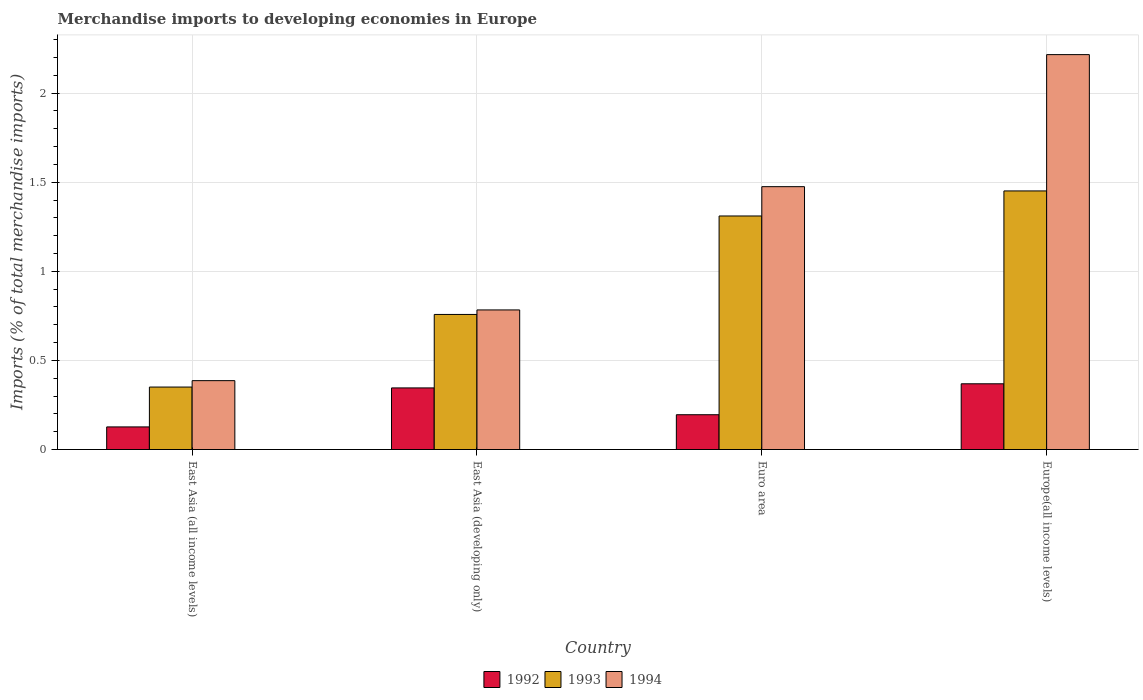How many different coloured bars are there?
Provide a short and direct response. 3. How many groups of bars are there?
Give a very brief answer. 4. Are the number of bars on each tick of the X-axis equal?
Ensure brevity in your answer.  Yes. What is the percentage total merchandise imports in 1994 in Europe(all income levels)?
Offer a very short reply. 2.22. Across all countries, what is the maximum percentage total merchandise imports in 1993?
Keep it short and to the point. 1.45. Across all countries, what is the minimum percentage total merchandise imports in 1992?
Offer a terse response. 0.13. In which country was the percentage total merchandise imports in 1993 maximum?
Provide a succinct answer. Europe(all income levels). In which country was the percentage total merchandise imports in 1993 minimum?
Ensure brevity in your answer.  East Asia (all income levels). What is the total percentage total merchandise imports in 1994 in the graph?
Make the answer very short. 4.86. What is the difference between the percentage total merchandise imports in 1992 in East Asia (developing only) and that in Europe(all income levels)?
Provide a short and direct response. -0.02. What is the difference between the percentage total merchandise imports in 1992 in East Asia (all income levels) and the percentage total merchandise imports in 1994 in Euro area?
Keep it short and to the point. -1.35. What is the average percentage total merchandise imports in 1993 per country?
Give a very brief answer. 0.97. What is the difference between the percentage total merchandise imports of/in 1993 and percentage total merchandise imports of/in 1994 in Euro area?
Offer a terse response. -0.16. In how many countries, is the percentage total merchandise imports in 1994 greater than 0.4 %?
Make the answer very short. 3. What is the ratio of the percentage total merchandise imports in 1993 in East Asia (all income levels) to that in Euro area?
Keep it short and to the point. 0.27. Is the difference between the percentage total merchandise imports in 1993 in East Asia (developing only) and Euro area greater than the difference between the percentage total merchandise imports in 1994 in East Asia (developing only) and Euro area?
Make the answer very short. Yes. What is the difference between the highest and the second highest percentage total merchandise imports in 1994?
Your response must be concise. -0.69. What is the difference between the highest and the lowest percentage total merchandise imports in 1994?
Make the answer very short. 1.83. Is the sum of the percentage total merchandise imports in 1993 in East Asia (all income levels) and East Asia (developing only) greater than the maximum percentage total merchandise imports in 1994 across all countries?
Provide a short and direct response. No. What does the 2nd bar from the left in Europe(all income levels) represents?
Ensure brevity in your answer.  1993. How many bars are there?
Give a very brief answer. 12. Are all the bars in the graph horizontal?
Provide a short and direct response. No. Are the values on the major ticks of Y-axis written in scientific E-notation?
Keep it short and to the point. No. Does the graph contain any zero values?
Offer a terse response. No. Where does the legend appear in the graph?
Provide a short and direct response. Bottom center. How many legend labels are there?
Offer a terse response. 3. How are the legend labels stacked?
Offer a very short reply. Horizontal. What is the title of the graph?
Your answer should be very brief. Merchandise imports to developing economies in Europe. Does "1992" appear as one of the legend labels in the graph?
Your answer should be compact. Yes. What is the label or title of the X-axis?
Give a very brief answer. Country. What is the label or title of the Y-axis?
Your response must be concise. Imports (% of total merchandise imports). What is the Imports (% of total merchandise imports) of 1992 in East Asia (all income levels)?
Your response must be concise. 0.13. What is the Imports (% of total merchandise imports) in 1993 in East Asia (all income levels)?
Offer a very short reply. 0.35. What is the Imports (% of total merchandise imports) of 1994 in East Asia (all income levels)?
Provide a succinct answer. 0.39. What is the Imports (% of total merchandise imports) in 1992 in East Asia (developing only)?
Your response must be concise. 0.35. What is the Imports (% of total merchandise imports) of 1993 in East Asia (developing only)?
Your response must be concise. 0.76. What is the Imports (% of total merchandise imports) in 1994 in East Asia (developing only)?
Keep it short and to the point. 0.78. What is the Imports (% of total merchandise imports) of 1992 in Euro area?
Ensure brevity in your answer.  0.2. What is the Imports (% of total merchandise imports) of 1993 in Euro area?
Make the answer very short. 1.31. What is the Imports (% of total merchandise imports) in 1994 in Euro area?
Offer a terse response. 1.48. What is the Imports (% of total merchandise imports) in 1992 in Europe(all income levels)?
Ensure brevity in your answer.  0.37. What is the Imports (% of total merchandise imports) of 1993 in Europe(all income levels)?
Keep it short and to the point. 1.45. What is the Imports (% of total merchandise imports) of 1994 in Europe(all income levels)?
Your response must be concise. 2.22. Across all countries, what is the maximum Imports (% of total merchandise imports) in 1992?
Offer a very short reply. 0.37. Across all countries, what is the maximum Imports (% of total merchandise imports) of 1993?
Your answer should be compact. 1.45. Across all countries, what is the maximum Imports (% of total merchandise imports) of 1994?
Keep it short and to the point. 2.22. Across all countries, what is the minimum Imports (% of total merchandise imports) of 1992?
Give a very brief answer. 0.13. Across all countries, what is the minimum Imports (% of total merchandise imports) of 1993?
Your answer should be very brief. 0.35. Across all countries, what is the minimum Imports (% of total merchandise imports) of 1994?
Offer a very short reply. 0.39. What is the total Imports (% of total merchandise imports) in 1992 in the graph?
Make the answer very short. 1.04. What is the total Imports (% of total merchandise imports) in 1993 in the graph?
Provide a succinct answer. 3.87. What is the total Imports (% of total merchandise imports) of 1994 in the graph?
Make the answer very short. 4.86. What is the difference between the Imports (% of total merchandise imports) in 1992 in East Asia (all income levels) and that in East Asia (developing only)?
Provide a succinct answer. -0.22. What is the difference between the Imports (% of total merchandise imports) in 1993 in East Asia (all income levels) and that in East Asia (developing only)?
Provide a short and direct response. -0.41. What is the difference between the Imports (% of total merchandise imports) in 1994 in East Asia (all income levels) and that in East Asia (developing only)?
Your answer should be compact. -0.4. What is the difference between the Imports (% of total merchandise imports) in 1992 in East Asia (all income levels) and that in Euro area?
Your response must be concise. -0.07. What is the difference between the Imports (% of total merchandise imports) of 1993 in East Asia (all income levels) and that in Euro area?
Your response must be concise. -0.96. What is the difference between the Imports (% of total merchandise imports) in 1994 in East Asia (all income levels) and that in Euro area?
Offer a terse response. -1.09. What is the difference between the Imports (% of total merchandise imports) in 1992 in East Asia (all income levels) and that in Europe(all income levels)?
Offer a very short reply. -0.24. What is the difference between the Imports (% of total merchandise imports) of 1993 in East Asia (all income levels) and that in Europe(all income levels)?
Offer a terse response. -1.1. What is the difference between the Imports (% of total merchandise imports) in 1994 in East Asia (all income levels) and that in Europe(all income levels)?
Ensure brevity in your answer.  -1.83. What is the difference between the Imports (% of total merchandise imports) in 1992 in East Asia (developing only) and that in Euro area?
Your answer should be compact. 0.15. What is the difference between the Imports (% of total merchandise imports) in 1993 in East Asia (developing only) and that in Euro area?
Provide a succinct answer. -0.55. What is the difference between the Imports (% of total merchandise imports) of 1994 in East Asia (developing only) and that in Euro area?
Provide a succinct answer. -0.69. What is the difference between the Imports (% of total merchandise imports) of 1992 in East Asia (developing only) and that in Europe(all income levels)?
Your response must be concise. -0.02. What is the difference between the Imports (% of total merchandise imports) in 1993 in East Asia (developing only) and that in Europe(all income levels)?
Offer a very short reply. -0.69. What is the difference between the Imports (% of total merchandise imports) of 1994 in East Asia (developing only) and that in Europe(all income levels)?
Make the answer very short. -1.43. What is the difference between the Imports (% of total merchandise imports) in 1992 in Euro area and that in Europe(all income levels)?
Offer a terse response. -0.17. What is the difference between the Imports (% of total merchandise imports) of 1993 in Euro area and that in Europe(all income levels)?
Your answer should be compact. -0.14. What is the difference between the Imports (% of total merchandise imports) in 1994 in Euro area and that in Europe(all income levels)?
Provide a short and direct response. -0.74. What is the difference between the Imports (% of total merchandise imports) in 1992 in East Asia (all income levels) and the Imports (% of total merchandise imports) in 1993 in East Asia (developing only)?
Offer a very short reply. -0.63. What is the difference between the Imports (% of total merchandise imports) of 1992 in East Asia (all income levels) and the Imports (% of total merchandise imports) of 1994 in East Asia (developing only)?
Your response must be concise. -0.66. What is the difference between the Imports (% of total merchandise imports) in 1993 in East Asia (all income levels) and the Imports (% of total merchandise imports) in 1994 in East Asia (developing only)?
Ensure brevity in your answer.  -0.43. What is the difference between the Imports (% of total merchandise imports) of 1992 in East Asia (all income levels) and the Imports (% of total merchandise imports) of 1993 in Euro area?
Your response must be concise. -1.18. What is the difference between the Imports (% of total merchandise imports) of 1992 in East Asia (all income levels) and the Imports (% of total merchandise imports) of 1994 in Euro area?
Offer a very short reply. -1.35. What is the difference between the Imports (% of total merchandise imports) of 1993 in East Asia (all income levels) and the Imports (% of total merchandise imports) of 1994 in Euro area?
Provide a succinct answer. -1.12. What is the difference between the Imports (% of total merchandise imports) of 1992 in East Asia (all income levels) and the Imports (% of total merchandise imports) of 1993 in Europe(all income levels)?
Offer a terse response. -1.32. What is the difference between the Imports (% of total merchandise imports) of 1992 in East Asia (all income levels) and the Imports (% of total merchandise imports) of 1994 in Europe(all income levels)?
Your answer should be compact. -2.09. What is the difference between the Imports (% of total merchandise imports) in 1993 in East Asia (all income levels) and the Imports (% of total merchandise imports) in 1994 in Europe(all income levels)?
Make the answer very short. -1.87. What is the difference between the Imports (% of total merchandise imports) of 1992 in East Asia (developing only) and the Imports (% of total merchandise imports) of 1993 in Euro area?
Give a very brief answer. -0.96. What is the difference between the Imports (% of total merchandise imports) of 1992 in East Asia (developing only) and the Imports (% of total merchandise imports) of 1994 in Euro area?
Offer a terse response. -1.13. What is the difference between the Imports (% of total merchandise imports) in 1993 in East Asia (developing only) and the Imports (% of total merchandise imports) in 1994 in Euro area?
Keep it short and to the point. -0.72. What is the difference between the Imports (% of total merchandise imports) of 1992 in East Asia (developing only) and the Imports (% of total merchandise imports) of 1993 in Europe(all income levels)?
Provide a succinct answer. -1.11. What is the difference between the Imports (% of total merchandise imports) of 1992 in East Asia (developing only) and the Imports (% of total merchandise imports) of 1994 in Europe(all income levels)?
Your response must be concise. -1.87. What is the difference between the Imports (% of total merchandise imports) of 1993 in East Asia (developing only) and the Imports (% of total merchandise imports) of 1994 in Europe(all income levels)?
Your response must be concise. -1.46. What is the difference between the Imports (% of total merchandise imports) in 1992 in Euro area and the Imports (% of total merchandise imports) in 1993 in Europe(all income levels)?
Your answer should be compact. -1.26. What is the difference between the Imports (% of total merchandise imports) in 1992 in Euro area and the Imports (% of total merchandise imports) in 1994 in Europe(all income levels)?
Offer a terse response. -2.02. What is the difference between the Imports (% of total merchandise imports) of 1993 in Euro area and the Imports (% of total merchandise imports) of 1994 in Europe(all income levels)?
Your answer should be compact. -0.91. What is the average Imports (% of total merchandise imports) of 1992 per country?
Make the answer very short. 0.26. What is the average Imports (% of total merchandise imports) of 1993 per country?
Give a very brief answer. 0.97. What is the average Imports (% of total merchandise imports) in 1994 per country?
Your answer should be compact. 1.22. What is the difference between the Imports (% of total merchandise imports) in 1992 and Imports (% of total merchandise imports) in 1993 in East Asia (all income levels)?
Offer a very short reply. -0.22. What is the difference between the Imports (% of total merchandise imports) in 1992 and Imports (% of total merchandise imports) in 1994 in East Asia (all income levels)?
Your answer should be compact. -0.26. What is the difference between the Imports (% of total merchandise imports) of 1993 and Imports (% of total merchandise imports) of 1994 in East Asia (all income levels)?
Keep it short and to the point. -0.04. What is the difference between the Imports (% of total merchandise imports) of 1992 and Imports (% of total merchandise imports) of 1993 in East Asia (developing only)?
Offer a terse response. -0.41. What is the difference between the Imports (% of total merchandise imports) in 1992 and Imports (% of total merchandise imports) in 1994 in East Asia (developing only)?
Offer a very short reply. -0.44. What is the difference between the Imports (% of total merchandise imports) of 1993 and Imports (% of total merchandise imports) of 1994 in East Asia (developing only)?
Offer a terse response. -0.03. What is the difference between the Imports (% of total merchandise imports) of 1992 and Imports (% of total merchandise imports) of 1993 in Euro area?
Offer a very short reply. -1.12. What is the difference between the Imports (% of total merchandise imports) of 1992 and Imports (% of total merchandise imports) of 1994 in Euro area?
Ensure brevity in your answer.  -1.28. What is the difference between the Imports (% of total merchandise imports) of 1993 and Imports (% of total merchandise imports) of 1994 in Euro area?
Ensure brevity in your answer.  -0.16. What is the difference between the Imports (% of total merchandise imports) in 1992 and Imports (% of total merchandise imports) in 1993 in Europe(all income levels)?
Your answer should be compact. -1.08. What is the difference between the Imports (% of total merchandise imports) in 1992 and Imports (% of total merchandise imports) in 1994 in Europe(all income levels)?
Your response must be concise. -1.85. What is the difference between the Imports (% of total merchandise imports) in 1993 and Imports (% of total merchandise imports) in 1994 in Europe(all income levels)?
Provide a succinct answer. -0.76. What is the ratio of the Imports (% of total merchandise imports) in 1992 in East Asia (all income levels) to that in East Asia (developing only)?
Your answer should be very brief. 0.37. What is the ratio of the Imports (% of total merchandise imports) of 1993 in East Asia (all income levels) to that in East Asia (developing only)?
Offer a very short reply. 0.46. What is the ratio of the Imports (% of total merchandise imports) of 1994 in East Asia (all income levels) to that in East Asia (developing only)?
Your answer should be compact. 0.49. What is the ratio of the Imports (% of total merchandise imports) of 1992 in East Asia (all income levels) to that in Euro area?
Your answer should be compact. 0.65. What is the ratio of the Imports (% of total merchandise imports) in 1993 in East Asia (all income levels) to that in Euro area?
Provide a short and direct response. 0.27. What is the ratio of the Imports (% of total merchandise imports) of 1994 in East Asia (all income levels) to that in Euro area?
Provide a succinct answer. 0.26. What is the ratio of the Imports (% of total merchandise imports) in 1992 in East Asia (all income levels) to that in Europe(all income levels)?
Make the answer very short. 0.34. What is the ratio of the Imports (% of total merchandise imports) in 1993 in East Asia (all income levels) to that in Europe(all income levels)?
Your answer should be compact. 0.24. What is the ratio of the Imports (% of total merchandise imports) in 1994 in East Asia (all income levels) to that in Europe(all income levels)?
Give a very brief answer. 0.17. What is the ratio of the Imports (% of total merchandise imports) of 1992 in East Asia (developing only) to that in Euro area?
Ensure brevity in your answer.  1.77. What is the ratio of the Imports (% of total merchandise imports) in 1993 in East Asia (developing only) to that in Euro area?
Keep it short and to the point. 0.58. What is the ratio of the Imports (% of total merchandise imports) of 1994 in East Asia (developing only) to that in Euro area?
Provide a succinct answer. 0.53. What is the ratio of the Imports (% of total merchandise imports) of 1992 in East Asia (developing only) to that in Europe(all income levels)?
Make the answer very short. 0.94. What is the ratio of the Imports (% of total merchandise imports) in 1993 in East Asia (developing only) to that in Europe(all income levels)?
Keep it short and to the point. 0.52. What is the ratio of the Imports (% of total merchandise imports) in 1994 in East Asia (developing only) to that in Europe(all income levels)?
Ensure brevity in your answer.  0.35. What is the ratio of the Imports (% of total merchandise imports) in 1992 in Euro area to that in Europe(all income levels)?
Make the answer very short. 0.53. What is the ratio of the Imports (% of total merchandise imports) of 1993 in Euro area to that in Europe(all income levels)?
Offer a very short reply. 0.9. What is the ratio of the Imports (% of total merchandise imports) of 1994 in Euro area to that in Europe(all income levels)?
Keep it short and to the point. 0.67. What is the difference between the highest and the second highest Imports (% of total merchandise imports) in 1992?
Provide a short and direct response. 0.02. What is the difference between the highest and the second highest Imports (% of total merchandise imports) in 1993?
Give a very brief answer. 0.14. What is the difference between the highest and the second highest Imports (% of total merchandise imports) in 1994?
Your answer should be compact. 0.74. What is the difference between the highest and the lowest Imports (% of total merchandise imports) of 1992?
Make the answer very short. 0.24. What is the difference between the highest and the lowest Imports (% of total merchandise imports) in 1993?
Provide a short and direct response. 1.1. What is the difference between the highest and the lowest Imports (% of total merchandise imports) in 1994?
Give a very brief answer. 1.83. 